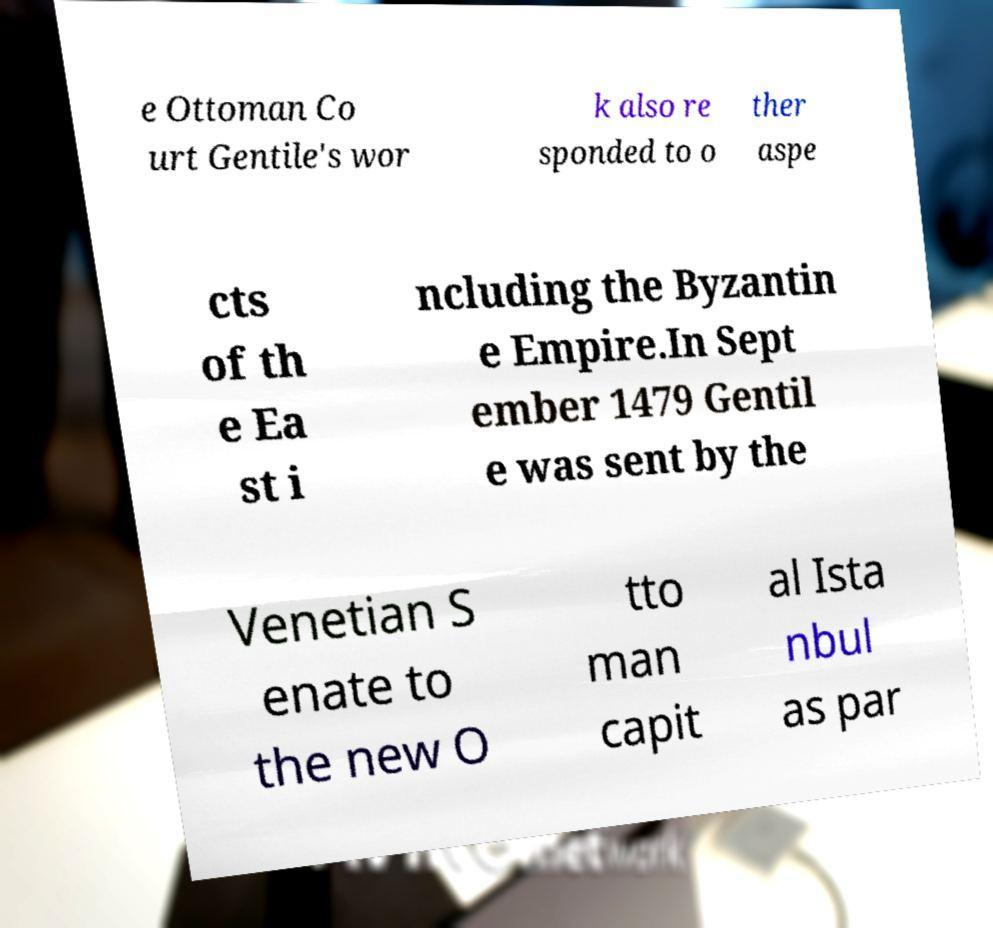Please identify and transcribe the text found in this image. e Ottoman Co urt Gentile's wor k also re sponded to o ther aspe cts of th e Ea st i ncluding the Byzantin e Empire.In Sept ember 1479 Gentil e was sent by the Venetian S enate to the new O tto man capit al Ista nbul as par 